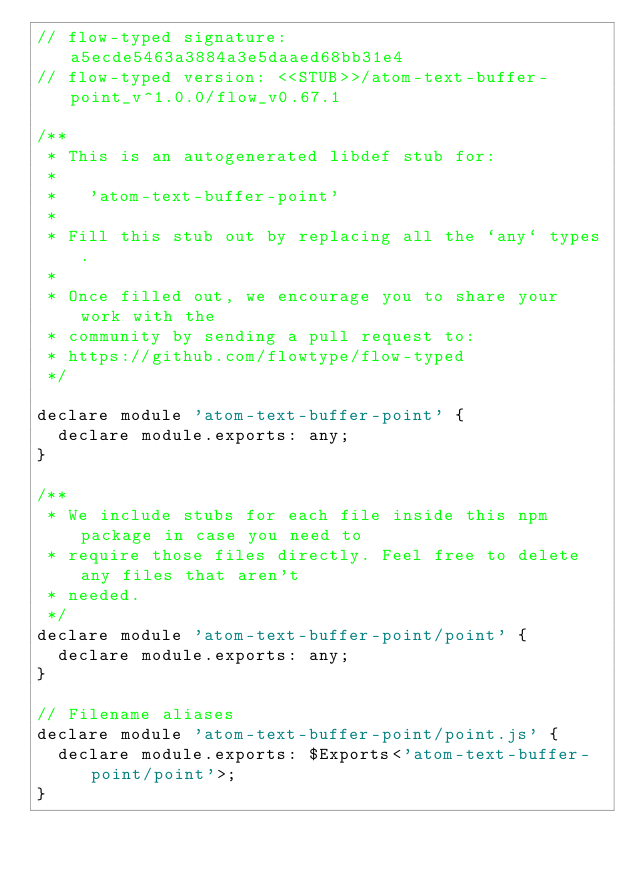<code> <loc_0><loc_0><loc_500><loc_500><_JavaScript_>// flow-typed signature: a5ecde5463a3884a3e5daaed68bb31e4
// flow-typed version: <<STUB>>/atom-text-buffer-point_v^1.0.0/flow_v0.67.1

/**
 * This is an autogenerated libdef stub for:
 *
 *   'atom-text-buffer-point'
 *
 * Fill this stub out by replacing all the `any` types.
 *
 * Once filled out, we encourage you to share your work with the
 * community by sending a pull request to:
 * https://github.com/flowtype/flow-typed
 */

declare module 'atom-text-buffer-point' {
  declare module.exports: any;
}

/**
 * We include stubs for each file inside this npm package in case you need to
 * require those files directly. Feel free to delete any files that aren't
 * needed.
 */
declare module 'atom-text-buffer-point/point' {
  declare module.exports: any;
}

// Filename aliases
declare module 'atom-text-buffer-point/point.js' {
  declare module.exports: $Exports<'atom-text-buffer-point/point'>;
}
</code> 